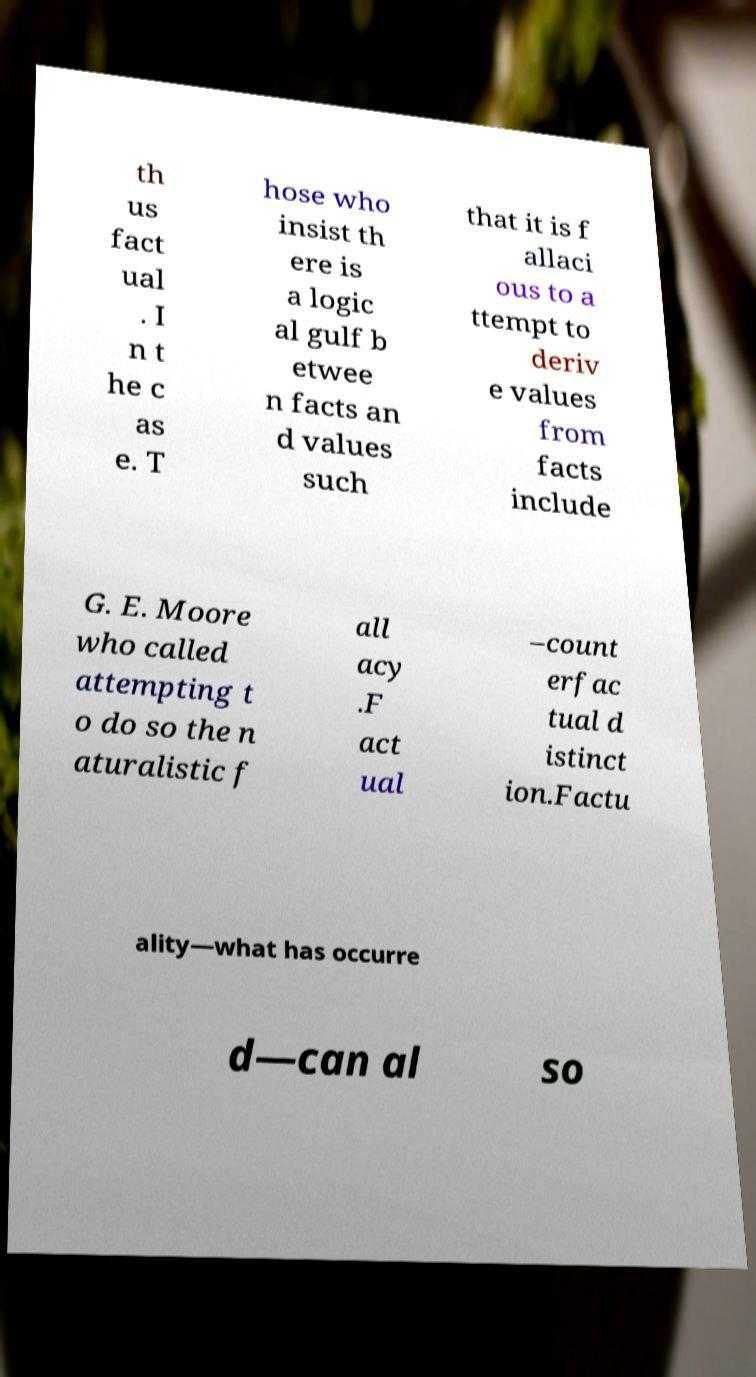Can you read and provide the text displayed in the image?This photo seems to have some interesting text. Can you extract and type it out for me? th us fact ual . I n t he c as e. T hose who insist th ere is a logic al gulf b etwee n facts an d values such that it is f allaci ous to a ttempt to deriv e values from facts include G. E. Moore who called attempting t o do so the n aturalistic f all acy .F act ual –count erfac tual d istinct ion.Factu ality—what has occurre d—can al so 